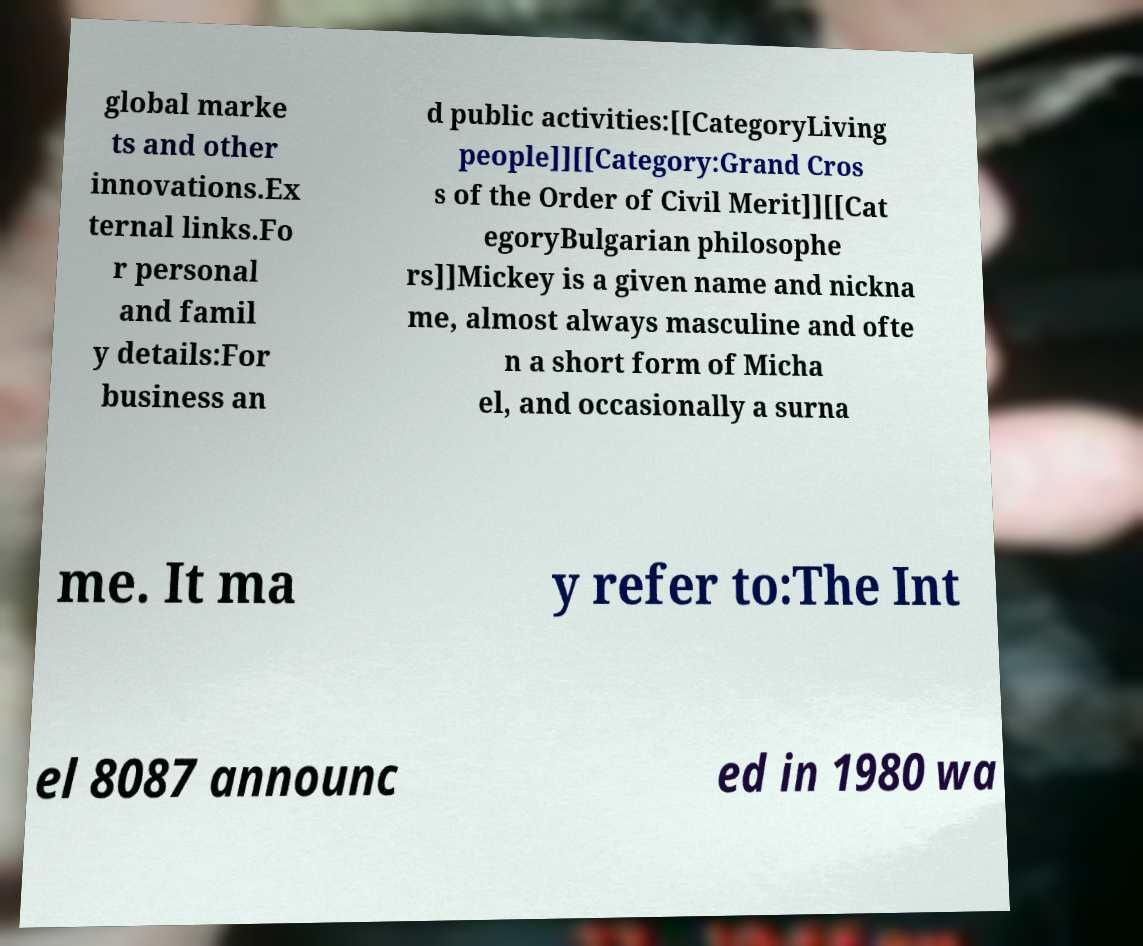I need the written content from this picture converted into text. Can you do that? global marke ts and other innovations.Ex ternal links.Fo r personal and famil y details:For business an d public activities:[[CategoryLiving people]][[Category:Grand Cros s of the Order of Civil Merit]][[Cat egoryBulgarian philosophe rs]]Mickey is a given name and nickna me, almost always masculine and ofte n a short form of Micha el, and occasionally a surna me. It ma y refer to:The Int el 8087 announc ed in 1980 wa 